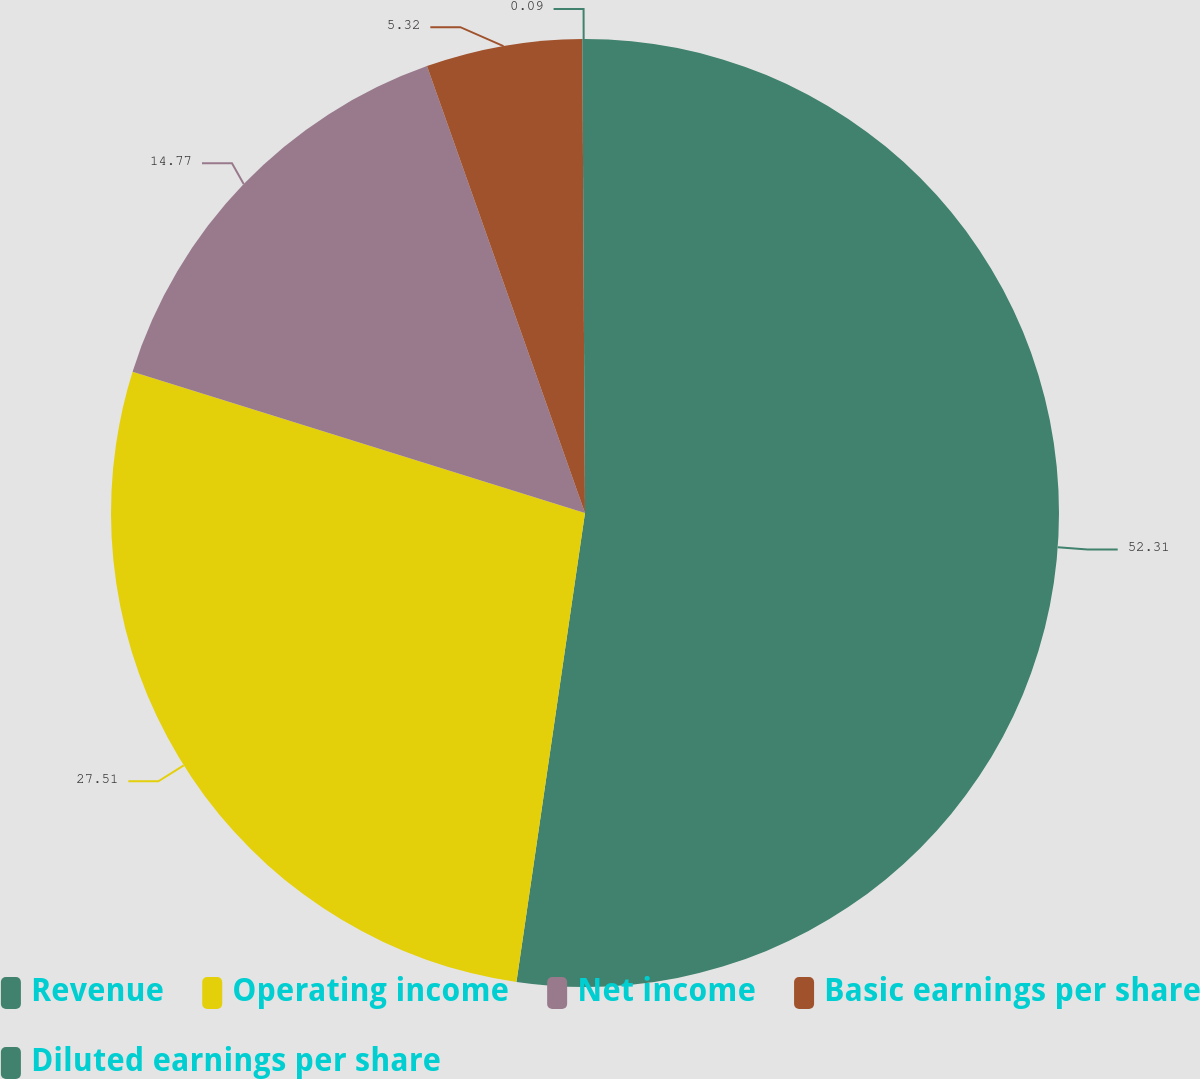Convert chart. <chart><loc_0><loc_0><loc_500><loc_500><pie_chart><fcel>Revenue<fcel>Operating income<fcel>Net income<fcel>Basic earnings per share<fcel>Diluted earnings per share<nl><fcel>52.31%<fcel>27.51%<fcel>14.77%<fcel>5.32%<fcel>0.09%<nl></chart> 